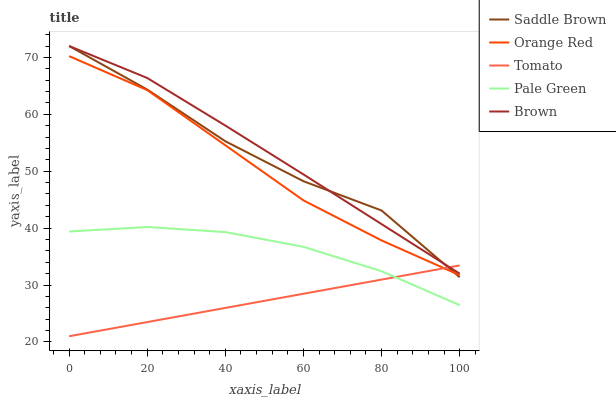Does Tomato have the minimum area under the curve?
Answer yes or no. Yes. Does Brown have the maximum area under the curve?
Answer yes or no. Yes. Does Pale Green have the minimum area under the curve?
Answer yes or no. No. Does Pale Green have the maximum area under the curve?
Answer yes or no. No. Is Tomato the smoothest?
Answer yes or no. Yes. Is Saddle Brown the roughest?
Answer yes or no. Yes. Is Brown the smoothest?
Answer yes or no. No. Is Brown the roughest?
Answer yes or no. No. Does Pale Green have the lowest value?
Answer yes or no. No. Does Saddle Brown have the highest value?
Answer yes or no. Yes. Does Pale Green have the highest value?
Answer yes or no. No. Is Orange Red less than Brown?
Answer yes or no. Yes. Is Orange Red greater than Pale Green?
Answer yes or no. Yes. Does Tomato intersect Orange Red?
Answer yes or no. Yes. Is Tomato less than Orange Red?
Answer yes or no. No. Is Tomato greater than Orange Red?
Answer yes or no. No. Does Orange Red intersect Brown?
Answer yes or no. No. 